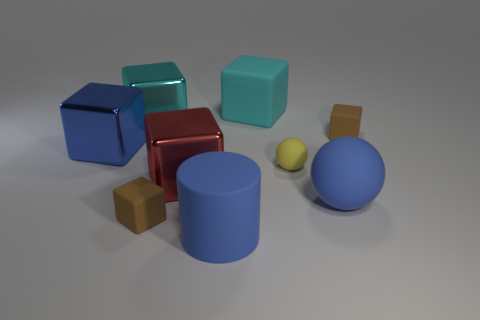Subtract all large rubber cubes. How many cubes are left? 5 Add 1 big blue blocks. How many objects exist? 10 Subtract all cyan cubes. How many cubes are left? 4 Subtract all cylinders. How many objects are left? 8 Subtract all red cubes. Subtract all cyan metallic things. How many objects are left? 7 Add 1 small brown objects. How many small brown objects are left? 3 Add 7 rubber blocks. How many rubber blocks exist? 10 Subtract 0 cyan spheres. How many objects are left? 9 Subtract 2 cubes. How many cubes are left? 4 Subtract all red spheres. Subtract all purple blocks. How many spheres are left? 2 